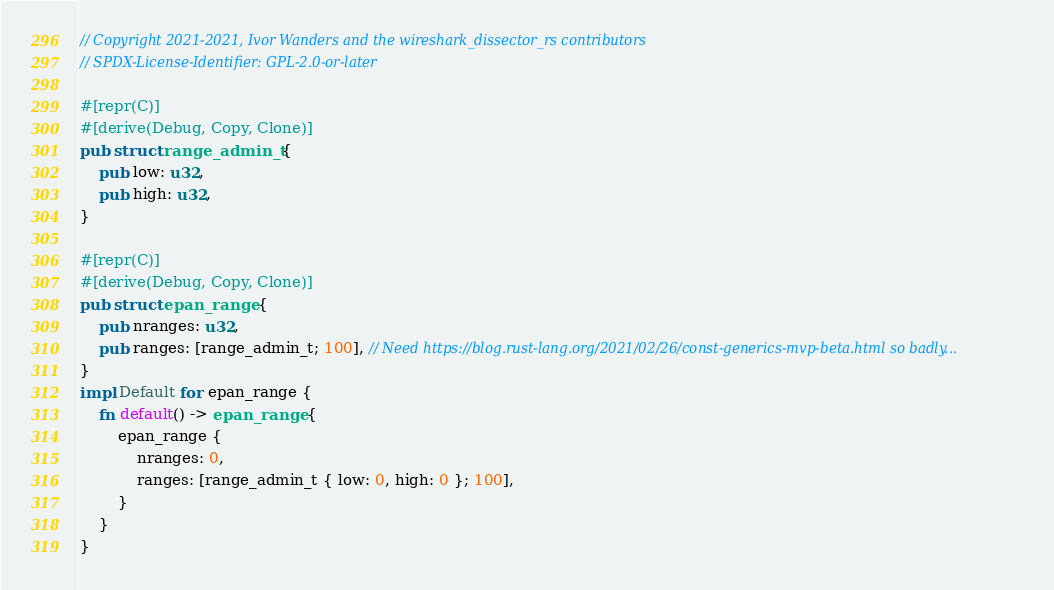<code> <loc_0><loc_0><loc_500><loc_500><_Rust_>// Copyright 2021-2021, Ivor Wanders and the wireshark_dissector_rs contributors
// SPDX-License-Identifier: GPL-2.0-or-later

#[repr(C)]
#[derive(Debug, Copy, Clone)]
pub struct range_admin_t {
    pub low: u32,
    pub high: u32,
}

#[repr(C)]
#[derive(Debug, Copy, Clone)]
pub struct epan_range {
    pub nranges: u32,
    pub ranges: [range_admin_t; 100], // Need https://blog.rust-lang.org/2021/02/26/const-generics-mvp-beta.html so badly...
}
impl Default for epan_range {
    fn default() -> epan_range {
        epan_range {
            nranges: 0,
            ranges: [range_admin_t { low: 0, high: 0 }; 100],
        }
    }
}
</code> 